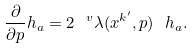Convert formula to latex. <formula><loc_0><loc_0><loc_500><loc_500>\frac { \partial } { \partial p } h _ { a } = 2 \ ^ { v } \lambda ( x ^ { k ^ { \prime } } , p ) \ h _ { a } .</formula> 